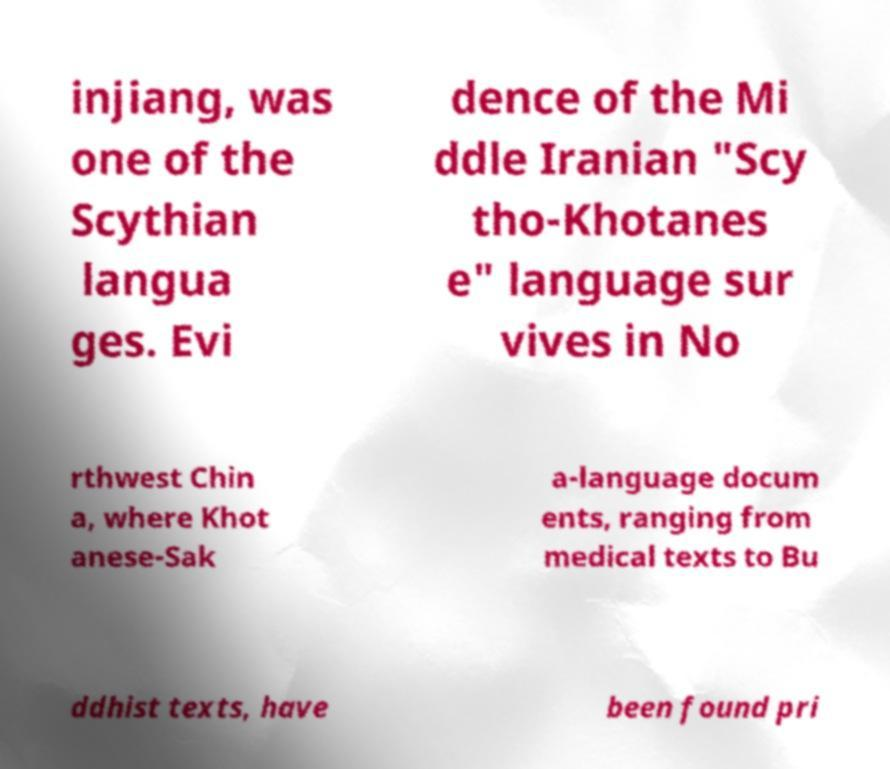What messages or text are displayed in this image? I need them in a readable, typed format. injiang, was one of the Scythian langua ges. Evi dence of the Mi ddle Iranian "Scy tho-Khotanes e" language sur vives in No rthwest Chin a, where Khot anese-Sak a-language docum ents, ranging from medical texts to Bu ddhist texts, have been found pri 